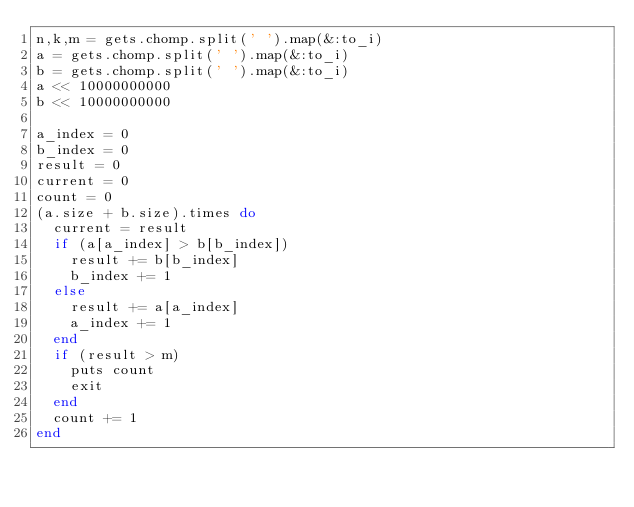<code> <loc_0><loc_0><loc_500><loc_500><_Ruby_>n,k,m = gets.chomp.split(' ').map(&:to_i)
a = gets.chomp.split(' ').map(&:to_i)
b = gets.chomp.split(' ').map(&:to_i)
a << 10000000000
b << 10000000000

a_index = 0
b_index = 0
result = 0
current = 0
count = 0
(a.size + b.size).times do
  current = result
  if (a[a_index] > b[b_index])
    result += b[b_index]
    b_index += 1
  else
    result += a[a_index]
    a_index += 1
  end
  if (result > m)
    puts count
    exit
  end
  count += 1
end</code> 